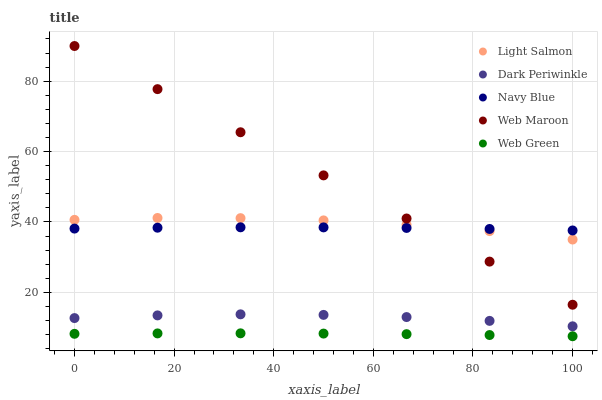Does Web Green have the minimum area under the curve?
Answer yes or no. Yes. Does Web Maroon have the maximum area under the curve?
Answer yes or no. Yes. Does Light Salmon have the minimum area under the curve?
Answer yes or no. No. Does Light Salmon have the maximum area under the curve?
Answer yes or no. No. Is Web Maroon the smoothest?
Answer yes or no. Yes. Is Light Salmon the roughest?
Answer yes or no. Yes. Is Light Salmon the smoothest?
Answer yes or no. No. Is Web Maroon the roughest?
Answer yes or no. No. Does Web Green have the lowest value?
Answer yes or no. Yes. Does Light Salmon have the lowest value?
Answer yes or no. No. Does Web Maroon have the highest value?
Answer yes or no. Yes. Does Light Salmon have the highest value?
Answer yes or no. No. Is Dark Periwinkle less than Web Maroon?
Answer yes or no. Yes. Is Web Maroon greater than Web Green?
Answer yes or no. Yes. Does Navy Blue intersect Light Salmon?
Answer yes or no. Yes. Is Navy Blue less than Light Salmon?
Answer yes or no. No. Is Navy Blue greater than Light Salmon?
Answer yes or no. No. Does Dark Periwinkle intersect Web Maroon?
Answer yes or no. No. 